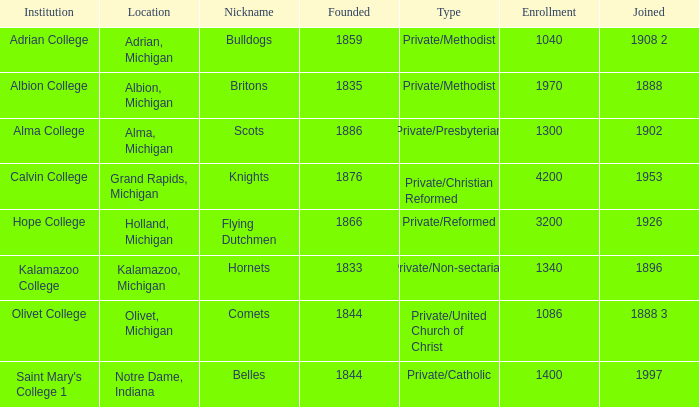In 1833, how many institutions were created? 1.0. Can you parse all the data within this table? {'header': ['Institution', 'Location', 'Nickname', 'Founded', 'Type', 'Enrollment', 'Joined'], 'rows': [['Adrian College', 'Adrian, Michigan', 'Bulldogs', '1859', 'Private/Methodist', '1040', '1908 2'], ['Albion College', 'Albion, Michigan', 'Britons', '1835', 'Private/Methodist', '1970', '1888'], ['Alma College', 'Alma, Michigan', 'Scots', '1886', 'Private/Presbyterian', '1300', '1902'], ['Calvin College', 'Grand Rapids, Michigan', 'Knights', '1876', 'Private/Christian Reformed', '4200', '1953'], ['Hope College', 'Holland, Michigan', 'Flying Dutchmen', '1866', 'Private/Reformed', '3200', '1926'], ['Kalamazoo College', 'Kalamazoo, Michigan', 'Hornets', '1833', 'Private/Non-sectarian', '1340', '1896'], ['Olivet College', 'Olivet, Michigan', 'Comets', '1844', 'Private/United Church of Christ', '1086', '1888 3'], ["Saint Mary's College 1", 'Notre Dame, Indiana', 'Belles', '1844', 'Private/Catholic', '1400', '1997']]} 